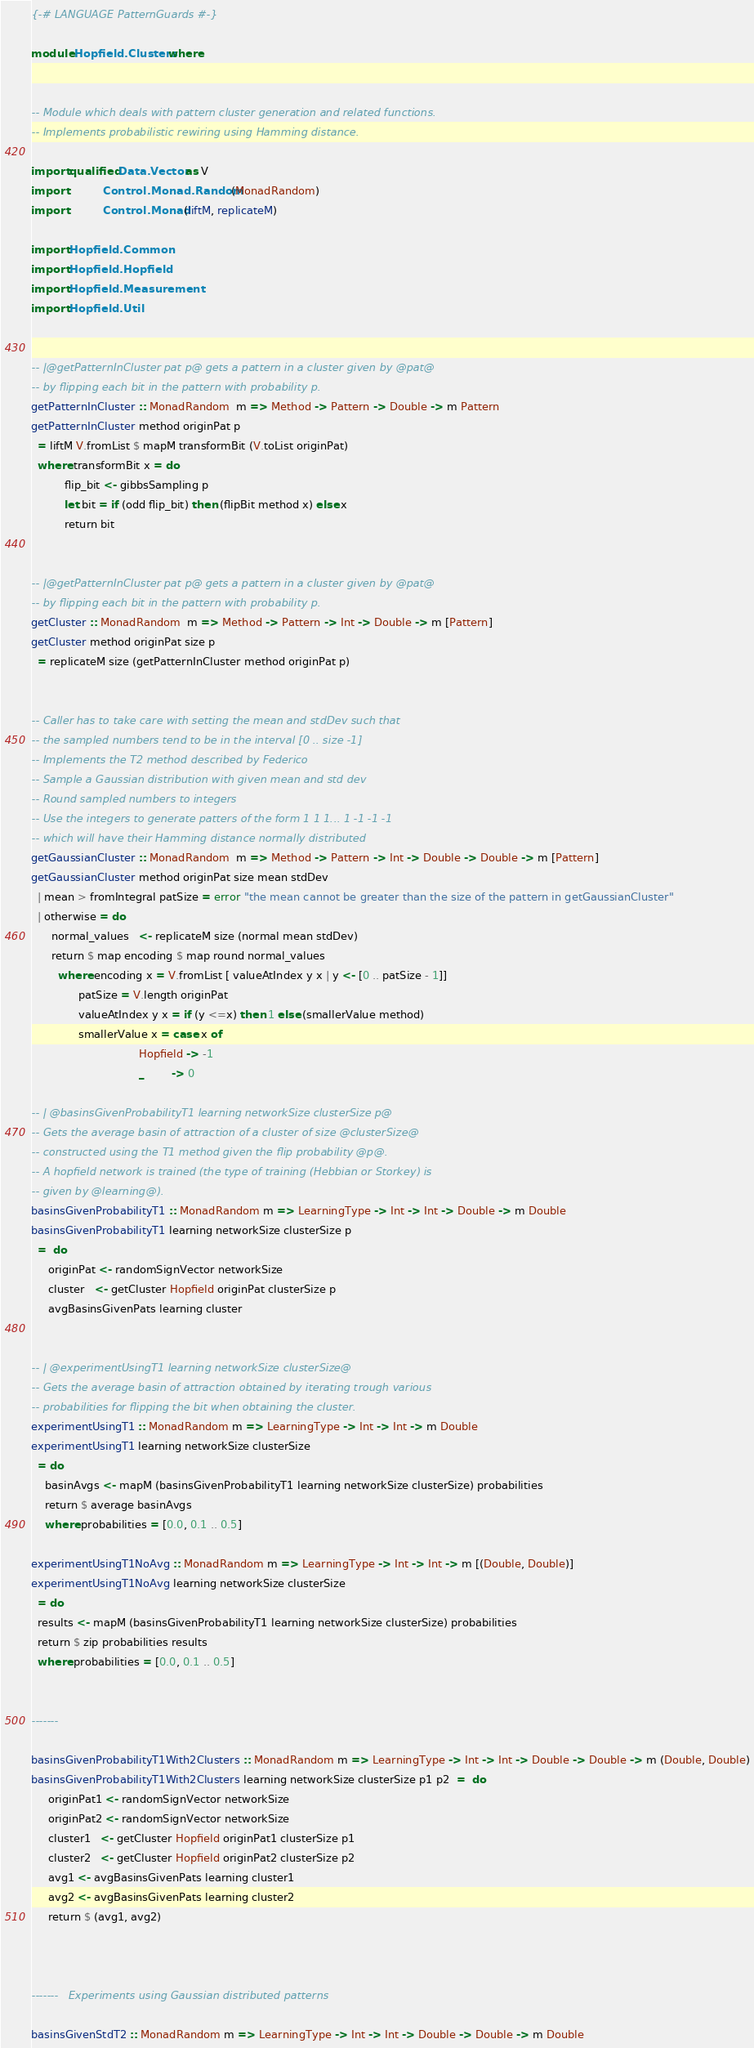<code> <loc_0><loc_0><loc_500><loc_500><_Haskell_>{-# LANGUAGE PatternGuards #-}

module Hopfield.Clusters where


-- Module which deals with pattern cluster generation and related functions.
-- Implements probabilistic rewiring using Hamming distance.

import qualified Data.Vector as V
import           Control.Monad.Random (MonadRandom)
import           Control.Monad (liftM, replicateM)

import Hopfield.Common
import Hopfield.Hopfield
import Hopfield.Measurement
import Hopfield.Util


-- |@getPatternInCluster pat p@ gets a pattern in a cluster given by @pat@
-- by flipping each bit in the pattern with probability p.
getPatternInCluster :: MonadRandom  m => Method -> Pattern -> Double -> m Pattern
getPatternInCluster method originPat p
  = liftM V.fromList $ mapM transformBit (V.toList originPat)
  where transformBit x = do
          flip_bit <- gibbsSampling p
          let bit = if (odd flip_bit) then (flipBit method x) else x
          return bit


-- |@getPatternInCluster pat p@ gets a pattern in a cluster given by @pat@
-- by flipping each bit in the pattern with probability p.
getCluster :: MonadRandom  m => Method -> Pattern -> Int -> Double -> m [Pattern]
getCluster method originPat size p
  = replicateM size (getPatternInCluster method originPat p)


-- Caller has to take care with setting the mean and stdDev such that
-- the sampled numbers tend to be in the interval [0 .. size -1]
-- Implements the T2 method described by Federico
-- Sample a Gaussian distribution with given mean and std dev
-- Round sampled numbers to integers
-- Use the integers to generate patters of the form 1 1 1... 1 -1 -1 -1
-- which will have their Hamming distance normally distributed
getGaussianCluster :: MonadRandom  m => Method -> Pattern -> Int -> Double -> Double -> m [Pattern]
getGaussianCluster method originPat size mean stdDev
  | mean > fromIntegral patSize = error "the mean cannot be greater than the size of the pattern in getGaussianCluster"
  | otherwise = do
      normal_values   <- replicateM size (normal mean stdDev)
      return $ map encoding $ map round normal_values
        where encoding x = V.fromList [ valueAtIndex y x | y <- [0 .. patSize - 1]]
              patSize = V.length originPat
              valueAtIndex y x = if (y <=x) then 1 else (smallerValue method)
              smallerValue x = case x of
                                Hopfield -> -1
                                _        -> 0

-- | @basinsGivenProbabilityT1 learning networkSize clusterSize p@
-- Gets the average basin of attraction of a cluster of size @clusterSize@
-- constructed using the T1 method given the flip probability @p@.
-- A hopfield network is trained (the type of training (Hebbian or Storkey) is
-- given by @learning@).
basinsGivenProbabilityT1 :: MonadRandom m => LearningType -> Int -> Int -> Double -> m Double
basinsGivenProbabilityT1 learning networkSize clusterSize p
  =  do
     originPat <- randomSignVector networkSize
     cluster   <- getCluster Hopfield originPat clusterSize p
     avgBasinsGivenPats learning cluster


-- | @experimentUsingT1 learning networkSize clusterSize@
-- Gets the average basin of attraction obtained by iterating trough various
-- probabilities for flipping the bit when obtaining the cluster.
experimentUsingT1 :: MonadRandom m => LearningType -> Int -> Int -> m Double
experimentUsingT1 learning networkSize clusterSize
  = do
    basinAvgs <- mapM (basinsGivenProbabilityT1 learning networkSize clusterSize) probabilities
    return $ average basinAvgs
    where probabilities = [0.0, 0.1 .. 0.5]

experimentUsingT1NoAvg :: MonadRandom m => LearningType -> Int -> Int -> m [(Double, Double)]
experimentUsingT1NoAvg learning networkSize clusterSize
  = do
  results <- mapM (basinsGivenProbabilityT1 learning networkSize clusterSize) probabilities
  return $ zip probabilities results
  where probabilities = [0.0, 0.1 .. 0.5]


-------

basinsGivenProbabilityT1With2Clusters :: MonadRandom m => LearningType -> Int -> Int -> Double -> Double -> m (Double, Double)
basinsGivenProbabilityT1With2Clusters learning networkSize clusterSize p1 p2  =  do
     originPat1 <- randomSignVector networkSize
     originPat2 <- randomSignVector networkSize
     cluster1   <- getCluster Hopfield originPat1 clusterSize p1
     cluster2   <- getCluster Hopfield originPat2 clusterSize p2
     avg1 <- avgBasinsGivenPats learning cluster1
     avg2 <- avgBasinsGivenPats learning cluster2
     return $ (avg1, avg2)



-------   Experiments using Gaussian distributed patterns

basinsGivenStdT2 :: MonadRandom m => LearningType -> Int -> Int -> Double -> Double -> m Double</code> 